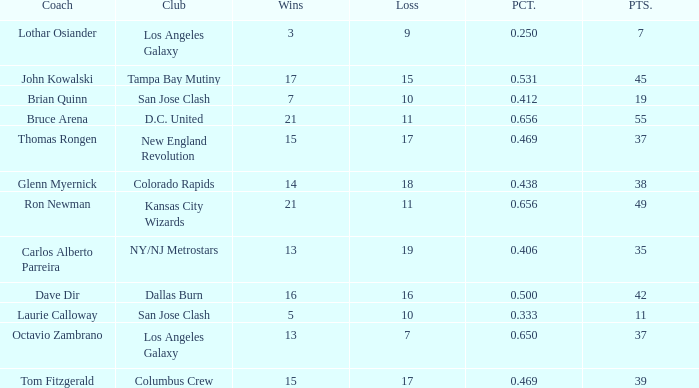What is the highest percent of Bruce Arena when he loses more than 11 games? None. 